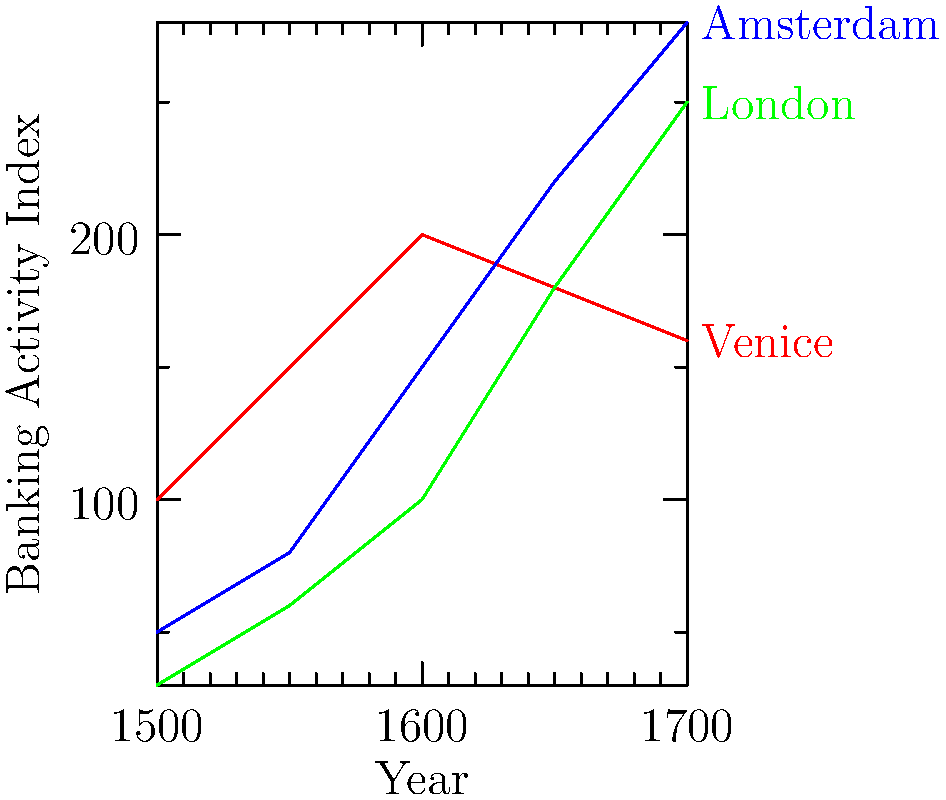Analyze the line graph showing the growth of early banking systems in Venice, Amsterdam, and London from 1500 to 1700. Which city experienced the most significant shift in its banking activity, and what economic factors might have contributed to this change? To determine which city experienced the most significant shift in banking activity, we need to analyze the trends for each city:

1. Venice:
   - Started at 100 in 1500
   - Peaked at 200 in 1600
   - Declined to 160 by 1700
   - Net change: +60 (60% increase)

2. Amsterdam:
   - Started at 50 in 1500
   - Steadily increased to 280 by 1700
   - Net change: +230 (460% increase)

3. London:
   - Started at 30 in 1500
   - Steadily increased to 250 by 1700
   - Net change: +220 (733% increase)

London experienced the most significant shift in terms of percentage growth (733%), while Amsterdam had the largest absolute increase (+230).

Economic factors contributing to London's growth:
1. Rise of the British Empire and colonial expansion
2. Establishment of the Bank of England in 1694
3. Growth of international trade, particularly in the Atlantic
4. Development of joint-stock companies and financial instruments

Amsterdam's growth can be attributed to:
1. Dutch Golden Age and maritime trade dominance
2. Establishment of the Amsterdam Exchange Bank in 1609
3. Innovation in financial instruments like futures and options

Venice's initial growth and subsequent decline can be explained by:
1. Early dominance in Mediterranean trade
2. Competition from emerging Atlantic trade routes
3. Decline of Venice as a maritime power

In conclusion, London experienced the most significant shift in banking activity, likely due to its rise as a global economic power and the establishment of key financial institutions.
Answer: London, due to 733% growth and the rise of the British Empire. 